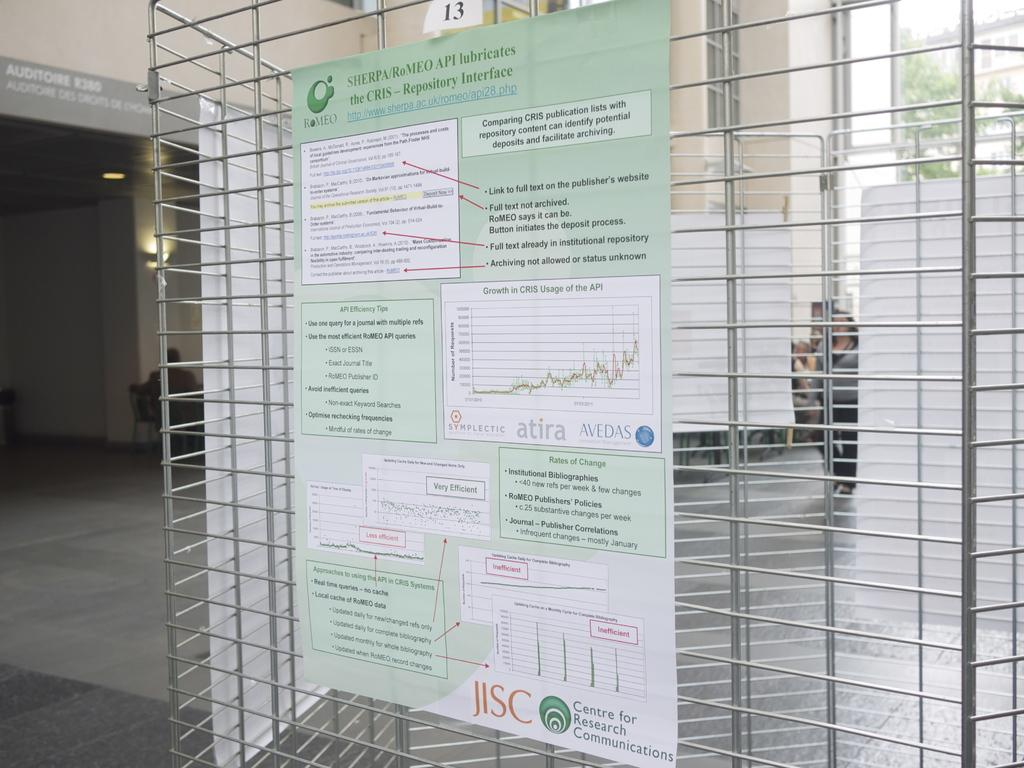What is on the grill in the image? There is a poster on the grill in the image. What can be seen illuminated in the image? There is a light in the image. What type of structure is visible in the image? There is a building in the image. What architectural feature is present in the building? There is a window in the image. What type of vegetation is present in the image? There is a tree in the image. What suggestion is written on the poster in the image? There is no suggestion written on the poster in the image; it is a poster on a grill. What type of caption can be seen on the light in the image? There is no caption on the light in the image; it is simply a light. 